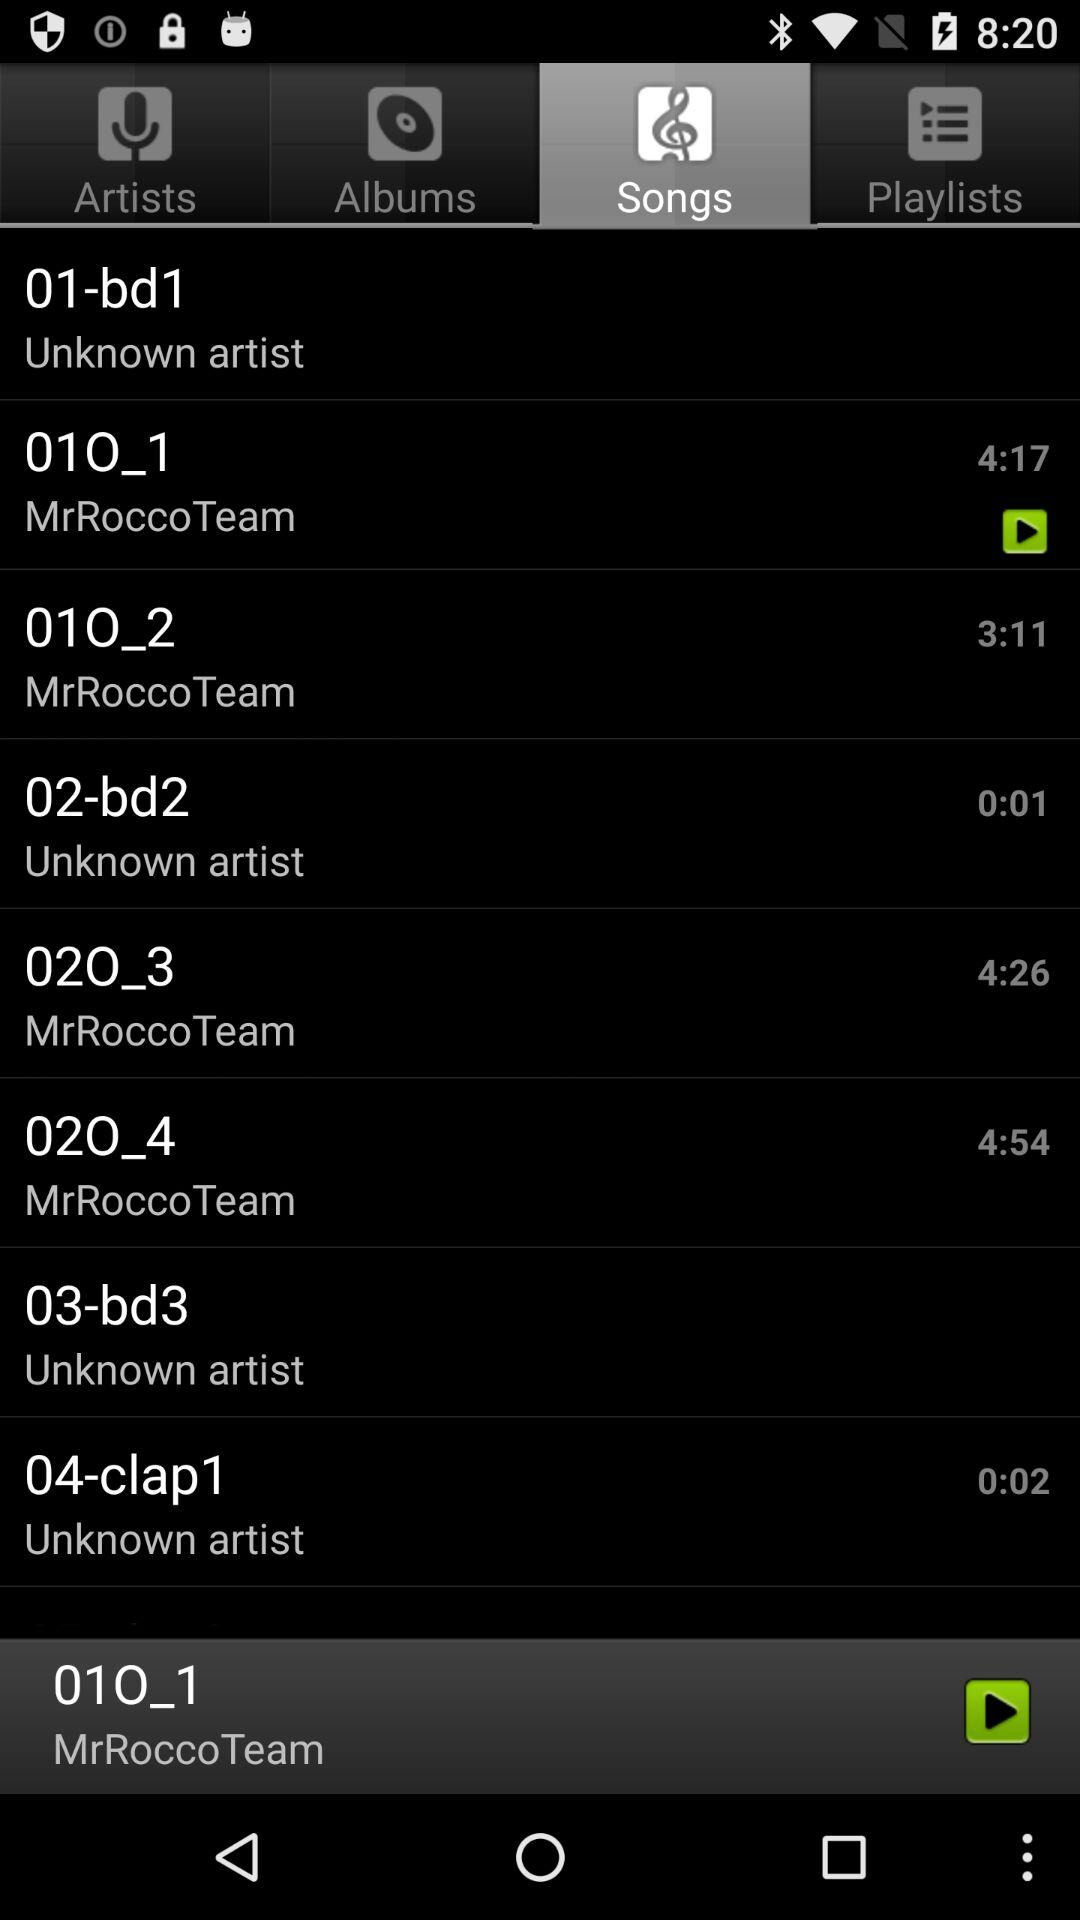Which song is currently selected? The currently selected song is "01O_1". 